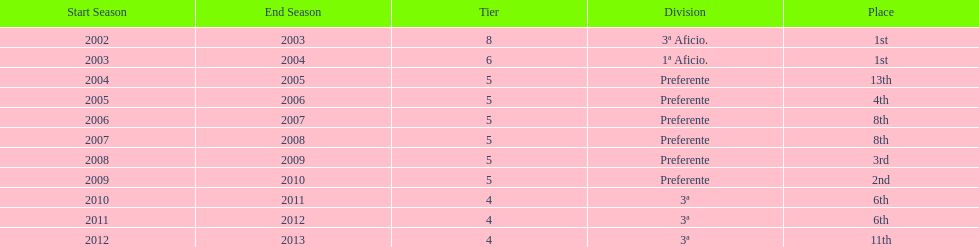How long has internacional de madrid cf been playing in the 3ª division? 3. 